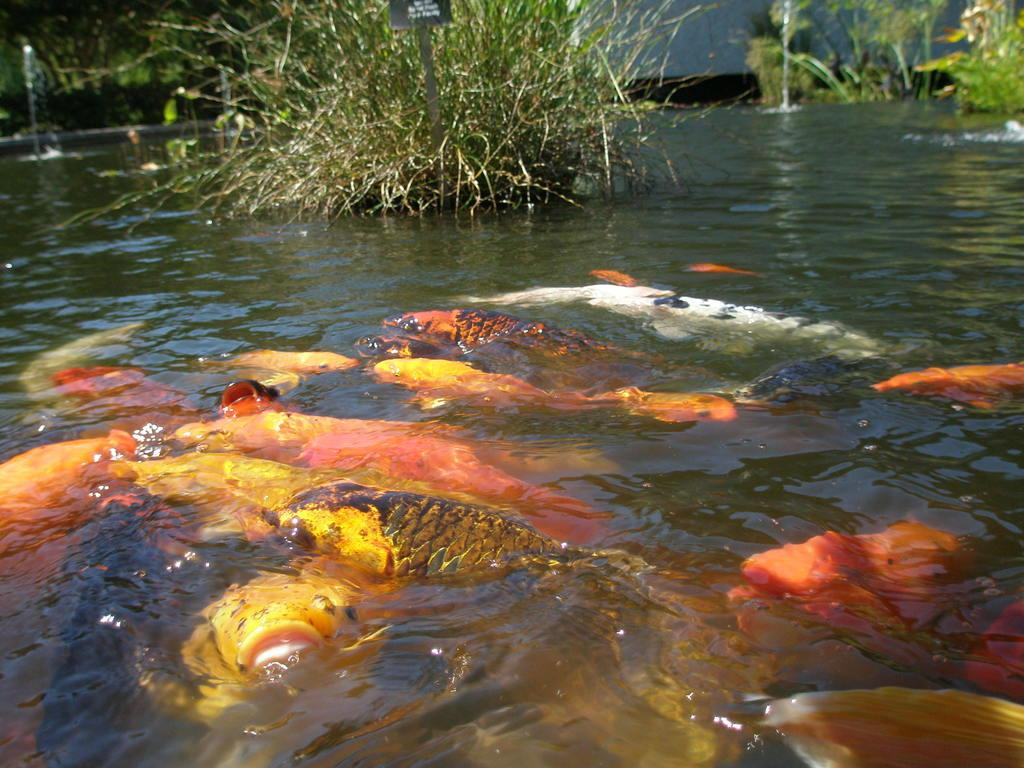What is at the bottom of the image? There is water at the bottom of the image. What can be found in the water? There are fishes in the water. What is located at the top of the image? There are plants at the top of the image. Can you see any bears interacting with the plants in the image? There are no bears present in the image; it features water, fishes, and plants. What type of glue is used to hold the houses together in the image? There are no houses present in the image; it features water, fishes, and plants. 